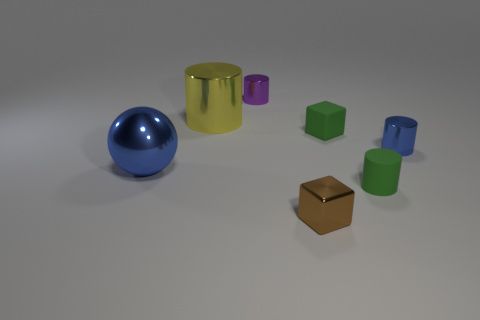There is a blue object left of the small shiny cylinder that is on the left side of the green cube; what is its shape? sphere 